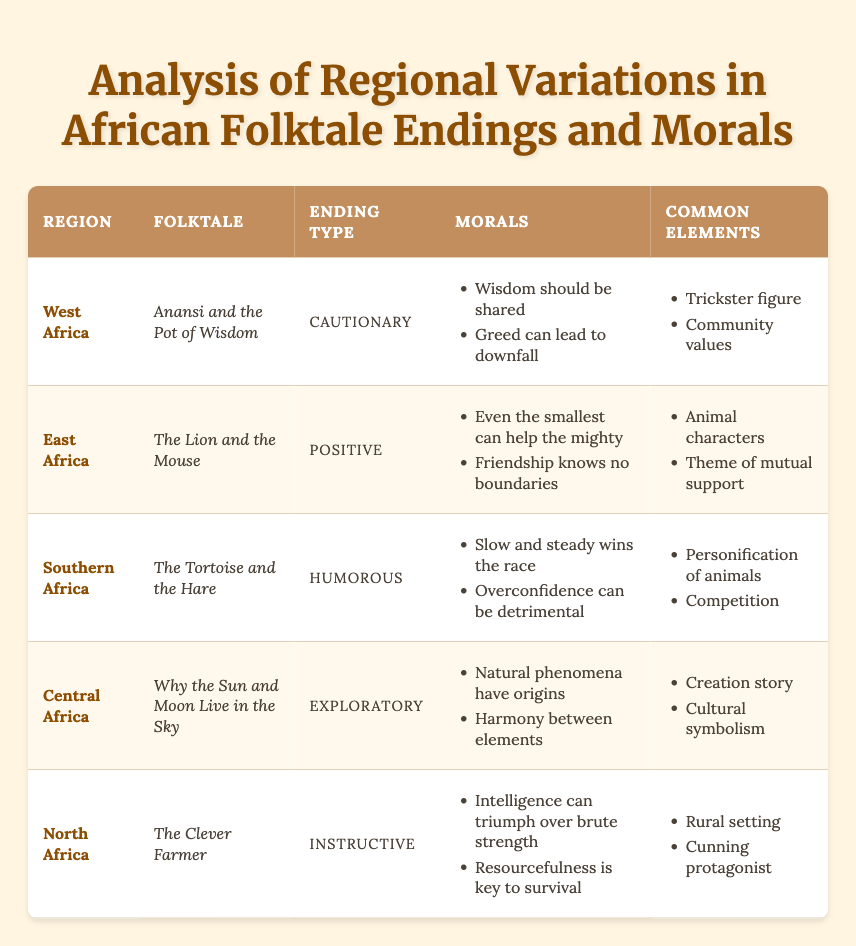What is the folktale from West Africa? The table lists "Anansi and the Pot of Wisdom" as the folktale from the West Africa region.
Answer: Anansi and the Pot of Wisdom Which region has a humorous folktale ending? In the table, Southern Africa corresponds to "The Tortoise and the Hare," which is categorized as having a humorous ending.
Answer: Southern Africa Do all the folktales emphasize themes of community and support? The table reveals that not all folktales emphasize community values; for example, "The Tortoise and the Hare" focuses on competition rather than community.
Answer: No How many different ending types are represented in the table? The table shows five distinct ending types: Cautionary, Positive, Humorous, Exploratory, and Instructive. Thus, there are five different types.
Answer: Five Is there a folktale from Central Africa that includes a creation story? The table indicates that "Why the Sun and Moon Live in the Sky" from Central Africa is indeed categorized as a creation story.
Answer: Yes What is the moral of the folktale from North Africa? The table states that the morals of "The Clever Farmer" from North Africa are that intelligence can triumph over brute strength and resourcefulness is key to survival.
Answer: Intelligence can triumph over brute strength; resourcefulness is key to survival Which region's folktale includes animal characters and has a positive ending? The table specifies that "The Lion and the Mouse" from East Africa includes animal characters and is categorized as having a positive ending.
Answer: East Africa Compare the common elements of West African and East African folktales. West African folktales have common elements of trickster figures and community values, while East African folktales feature animal characters and a theme of mutual support.
Answer: Trickster figures and community values vs. animal characters and mutual support What is the relationship between ending type and region in this table? The table demonstrates that each region has a unique folktale associated with a specific ending type. For example, Cautionary is linked to West Africa, while Positive is linked to East Africa. This suggests a variety of narrative styles across regions.
Answer: Each region has a unique folktale with a specific ending type 